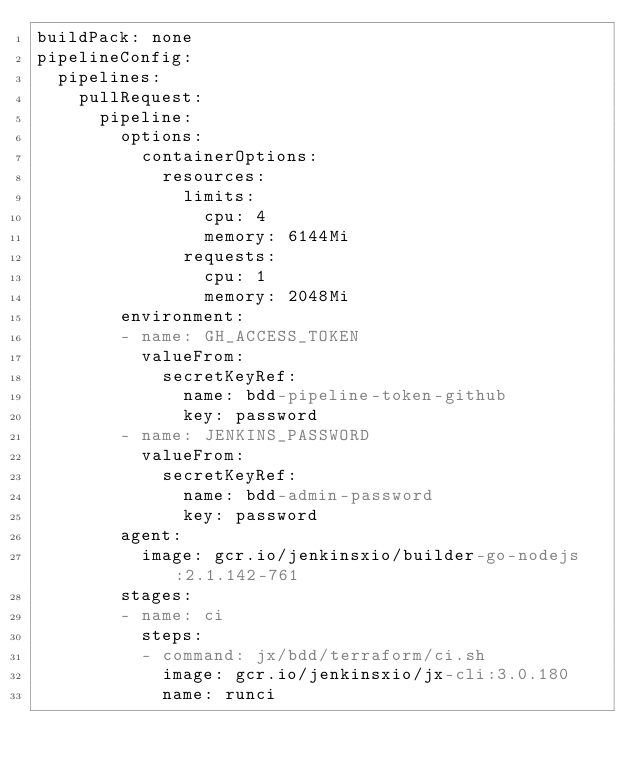<code> <loc_0><loc_0><loc_500><loc_500><_YAML_>buildPack: none
pipelineConfig:
  pipelines:
    pullRequest:
      pipeline:
        options:
          containerOptions:
            resources:
              limits:
                cpu: 4
                memory: 6144Mi
              requests:
                cpu: 1
                memory: 2048Mi
        environment:
        - name: GH_ACCESS_TOKEN
          valueFrom:
            secretKeyRef:
              name: bdd-pipeline-token-github
              key: password
        - name: JENKINS_PASSWORD
          valueFrom:
            secretKeyRef:
              name: bdd-admin-password
              key: password
        agent:
          image: gcr.io/jenkinsxio/builder-go-nodejs:2.1.142-761
        stages:
        - name: ci
          steps:
          - command: jx/bdd/terraform/ci.sh
            image: gcr.io/jenkinsxio/jx-cli:3.0.180
            name: runci
</code> 